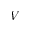Convert formula to latex. <formula><loc_0><loc_0><loc_500><loc_500>V</formula> 